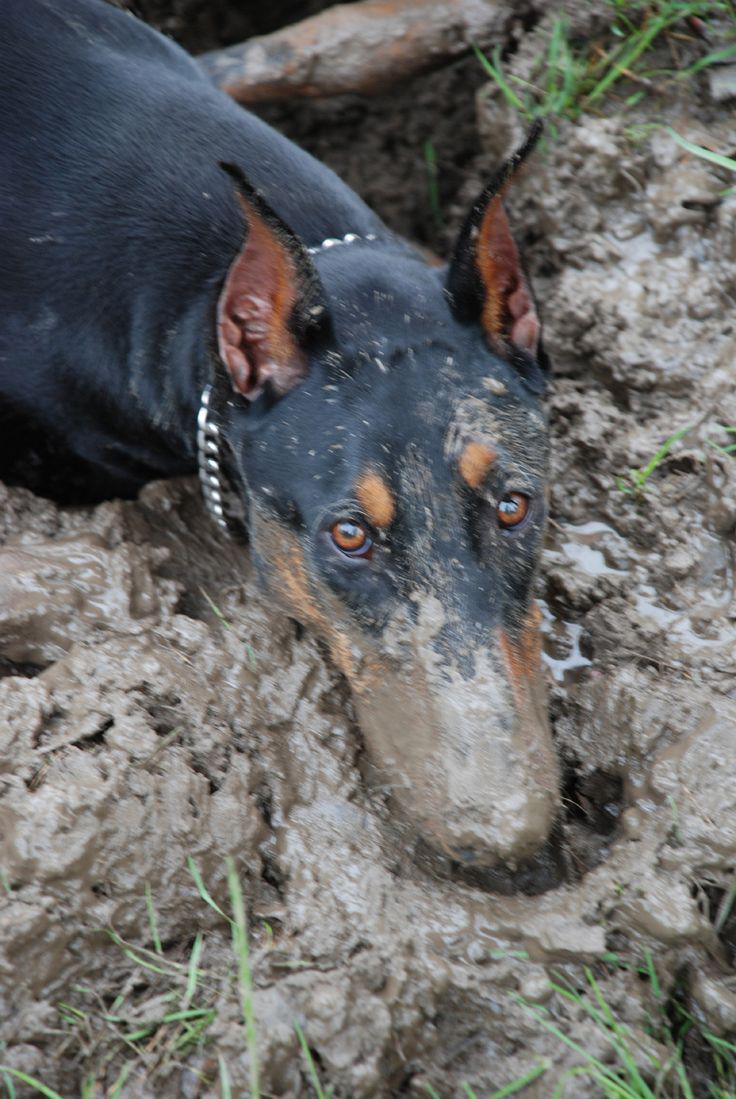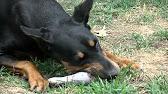The first image is the image on the left, the second image is the image on the right. For the images displayed, is the sentence "The right image features one doberman with its front paws forward on the ground and its mouth on a pale object on the grass." factually correct? Answer yes or no. Yes. 